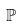Convert formula to latex. <formula><loc_0><loc_0><loc_500><loc_500>\mathbb { P }</formula> 